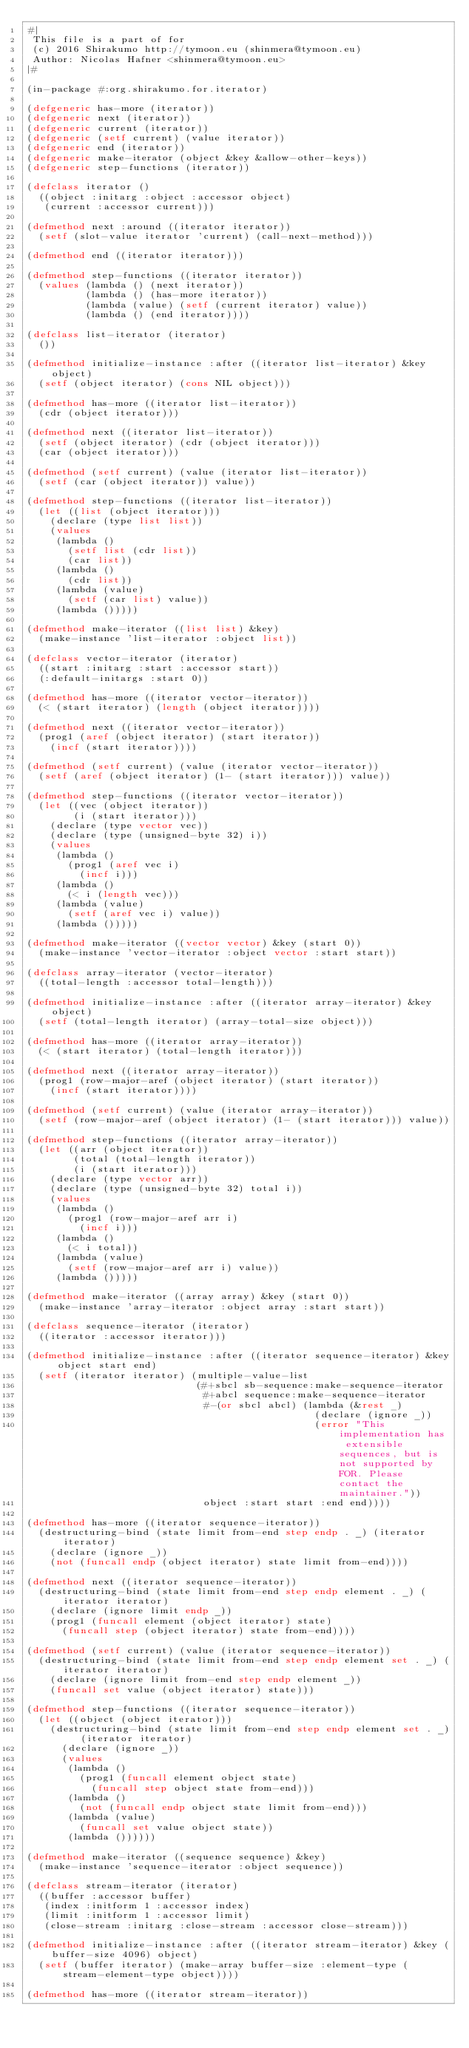Convert code to text. <code><loc_0><loc_0><loc_500><loc_500><_Lisp_>#|
 This file is a part of for
 (c) 2016 Shirakumo http://tymoon.eu (shinmera@tymoon.eu)
 Author: Nicolas Hafner <shinmera@tymoon.eu>
|#

(in-package #:org.shirakumo.for.iterator)

(defgeneric has-more (iterator))
(defgeneric next (iterator))
(defgeneric current (iterator))
(defgeneric (setf current) (value iterator))
(defgeneric end (iterator))
(defgeneric make-iterator (object &key &allow-other-keys))
(defgeneric step-functions (iterator))

(defclass iterator ()
  ((object :initarg :object :accessor object)
   (current :accessor current)))

(defmethod next :around ((iterator iterator))
  (setf (slot-value iterator 'current) (call-next-method)))

(defmethod end ((iterator iterator)))

(defmethod step-functions ((iterator iterator))
  (values (lambda () (next iterator))
          (lambda () (has-more iterator))
          (lambda (value) (setf (current iterator) value))
          (lambda () (end iterator))))

(defclass list-iterator (iterator)
  ())

(defmethod initialize-instance :after ((iterator list-iterator) &key object)
  (setf (object iterator) (cons NIL object)))

(defmethod has-more ((iterator list-iterator))
  (cdr (object iterator)))

(defmethod next ((iterator list-iterator))
  (setf (object iterator) (cdr (object iterator)))
  (car (object iterator)))

(defmethod (setf current) (value (iterator list-iterator))
  (setf (car (object iterator)) value))

(defmethod step-functions ((iterator list-iterator))
  (let ((list (object iterator)))
    (declare (type list list))
    (values
     (lambda ()
       (setf list (cdr list))
       (car list))
     (lambda ()
       (cdr list))
     (lambda (value)
       (setf (car list) value))
     (lambda ()))))

(defmethod make-iterator ((list list) &key)
  (make-instance 'list-iterator :object list))

(defclass vector-iterator (iterator)
  ((start :initarg :start :accessor start))
  (:default-initargs :start 0))

(defmethod has-more ((iterator vector-iterator))
  (< (start iterator) (length (object iterator))))

(defmethod next ((iterator vector-iterator))
  (prog1 (aref (object iterator) (start iterator))
    (incf (start iterator))))

(defmethod (setf current) (value (iterator vector-iterator))
  (setf (aref (object iterator) (1- (start iterator))) value))

(defmethod step-functions ((iterator vector-iterator))
  (let ((vec (object iterator))
        (i (start iterator)))
    (declare (type vector vec))
    (declare (type (unsigned-byte 32) i))
    (values
     (lambda ()
       (prog1 (aref vec i)
         (incf i)))
     (lambda ()
       (< i (length vec)))
     (lambda (value)
       (setf (aref vec i) value))
     (lambda ()))))

(defmethod make-iterator ((vector vector) &key (start 0))
  (make-instance 'vector-iterator :object vector :start start))

(defclass array-iterator (vector-iterator)
  ((total-length :accessor total-length)))

(defmethod initialize-instance :after ((iterator array-iterator) &key object)
  (setf (total-length iterator) (array-total-size object)))

(defmethod has-more ((iterator array-iterator))
  (< (start iterator) (total-length iterator)))

(defmethod next ((iterator array-iterator))
  (prog1 (row-major-aref (object iterator) (start iterator))
    (incf (start iterator))))

(defmethod (setf current) (value (iterator array-iterator))
  (setf (row-major-aref (object iterator) (1- (start iterator))) value))

(defmethod step-functions ((iterator array-iterator))
  (let ((arr (object iterator))
        (total (total-length iterator))
        (i (start iterator)))
    (declare (type vector arr))
    (declare (type (unsigned-byte 32) total i))
    (values
     (lambda ()
       (prog1 (row-major-aref arr i)
         (incf i)))
     (lambda ()
       (< i total))
     (lambda (value)
       (setf (row-major-aref arr i) value))
     (lambda ()))))

(defmethod make-iterator ((array array) &key (start 0))
  (make-instance 'array-iterator :object array :start start))

(defclass sequence-iterator (iterator)
  ((iterator :accessor iterator)))

(defmethod initialize-instance :after ((iterator sequence-iterator) &key object start end)
  (setf (iterator iterator) (multiple-value-list
                             (#+sbcl sb-sequence:make-sequence-iterator
                              #+abcl sequence:make-sequence-iterator
                              #-(or sbcl abcl) (lambda (&rest _)
                                                 (declare (ignore _))
                                                 (error "This implementation has extensible sequences, but is not supported by FOR. Please contact the maintainer."))
                              object :start start :end end))))

(defmethod has-more ((iterator sequence-iterator))
  (destructuring-bind (state limit from-end step endp . _) (iterator iterator)
    (declare (ignore _))
    (not (funcall endp (object iterator) state limit from-end))))

(defmethod next ((iterator sequence-iterator))
  (destructuring-bind (state limit from-end step endp element . _) (iterator iterator)
    (declare (ignore limit endp _))
    (prog1 (funcall element (object iterator) state)
      (funcall step (object iterator) state from-end))))

(defmethod (setf current) (value (iterator sequence-iterator))
  (destructuring-bind (state limit from-end step endp element set . _) (iterator iterator)
    (declare (ignore limit from-end step endp element _))
    (funcall set value (object iterator) state)))

(defmethod step-functions ((iterator sequence-iterator))
  (let ((object (object iterator)))
    (destructuring-bind (state limit from-end step endp element set . _) (iterator iterator)
      (declare (ignore _))
      (values
       (lambda ()
         (prog1 (funcall element object state)
           (funcall step object state from-end)))
       (lambda ()
         (not (funcall endp object state limit from-end)))
       (lambda (value)
         (funcall set value object state))
       (lambda ())))))

(defmethod make-iterator ((sequence sequence) &key)
  (make-instance 'sequence-iterator :object sequence))

(defclass stream-iterator (iterator)
  ((buffer :accessor buffer)
   (index :initform 1 :accessor index)
   (limit :initform 1 :accessor limit)
   (close-stream :initarg :close-stream :accessor close-stream)))

(defmethod initialize-instance :after ((iterator stream-iterator) &key (buffer-size 4096) object)
  (setf (buffer iterator) (make-array buffer-size :element-type (stream-element-type object))))

(defmethod has-more ((iterator stream-iterator))</code> 